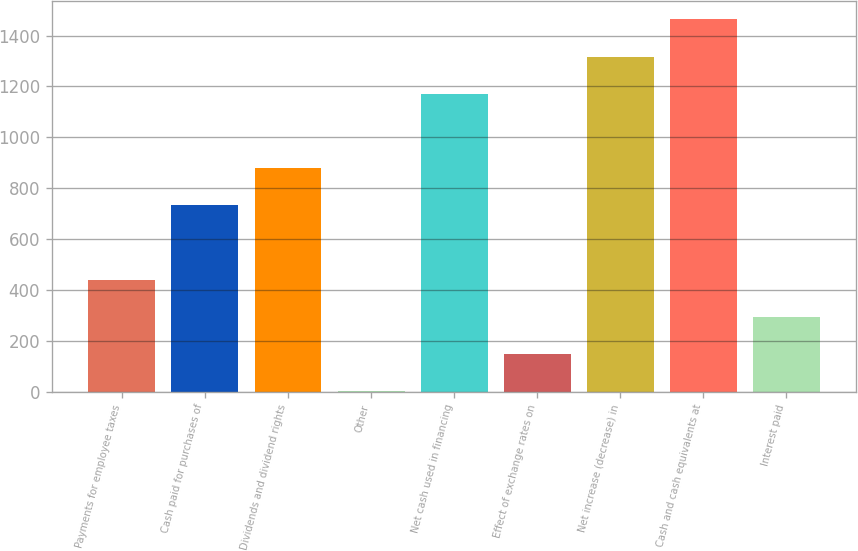Convert chart to OTSL. <chart><loc_0><loc_0><loc_500><loc_500><bar_chart><fcel>Payments for employee taxes<fcel>Cash paid for purchases of<fcel>Dividends and dividend rights<fcel>Other<fcel>Net cash used in financing<fcel>Effect of exchange rates on<fcel>Net increase (decrease) in<fcel>Cash and cash equivalents at<fcel>Interest paid<nl><fcel>439.9<fcel>732.5<fcel>878.8<fcel>1<fcel>1171.4<fcel>147.3<fcel>1317.7<fcel>1464<fcel>293.6<nl></chart> 